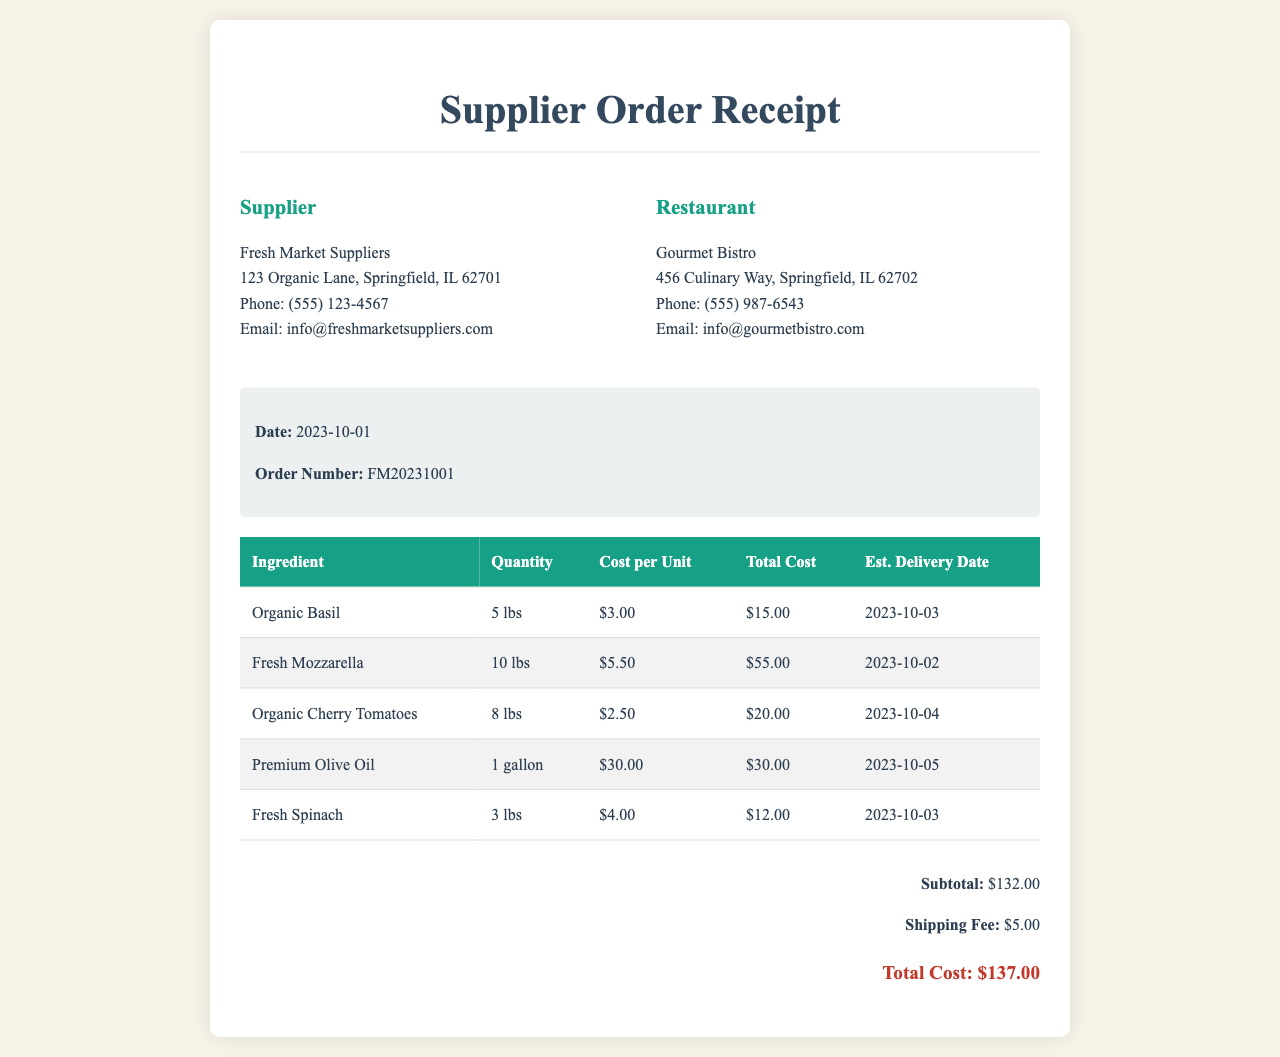What is the name of the supplier? The supplier's name is listed at the top of the document under supplier information.
Answer: Fresh Market Suppliers What is the cost of 1 gallon of Premium Olive Oil? The cost per unit for Premium Olive Oil is shown in the table under the cost column.
Answer: $30.00 When is the estimated delivery date for Fresh Mozzarella? The estimated delivery date is specified in the table next to the ingredient Fresh Mozzarella.
Answer: 2023-10-02 How many pounds of Organic Basil were ordered? The quantity ordered is provided in the table corresponding to Organic Basil.
Answer: 5 lbs What is the total cost of the order? The total cost is clearly stated in the summary section at the bottom of the document.
Answer: $137.00 What is the order number for this receipt? The order number is specified in the receipt details section.
Answer: FM20231001 What is the subtotal before shipping fees? The subtotal can be found in the summary section prior to shipping fees.
Answer: $132.00 Which ingredient has the highest cost per unit? The highest cost per unit can be determined by reviewing the cost column for each ingredient.
Answer: Fresh Mozzarella How many types of ingredients are listed in the order? The types of ingredients can be counted from the table listing various items.
Answer: 5 